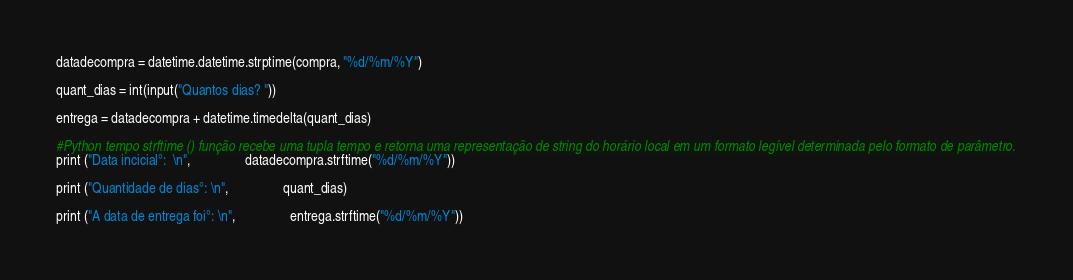<code> <loc_0><loc_0><loc_500><loc_500><_Python_>datadecompra = datetime.datetime.strptime(compra, "%d/%m/%Y")

quant_dias = int(input("Quantos dias? "))

entrega = datadecompra + datetime.timedelta(quant_dias)

#Python tempo strftime () função recebe uma tupla tempo e retorna uma representação de string do horário local em um formato legível determinada pelo formato de parâmetro.
print ("Data incicial°:  \n",                datadecompra.strftime("%d/%m/%Y"))

print ("Quantidade de dias°: \n",                quant_dias)

print ("A data de entrega foi°: \n",                entrega.strftime("%d/%m/%Y"))
</code> 